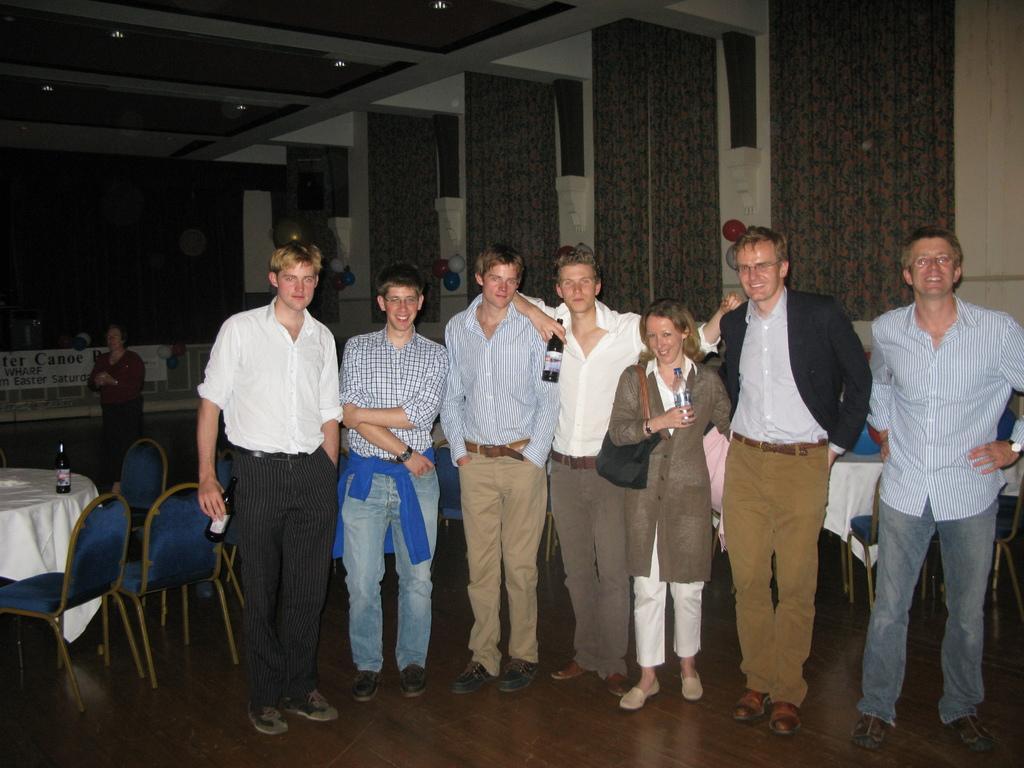Please provide a concise description of this image. In this image we can see people standing and we can also see some people holding bottles in their hands. Behind them, we can see chairs, table, bottles and light. 